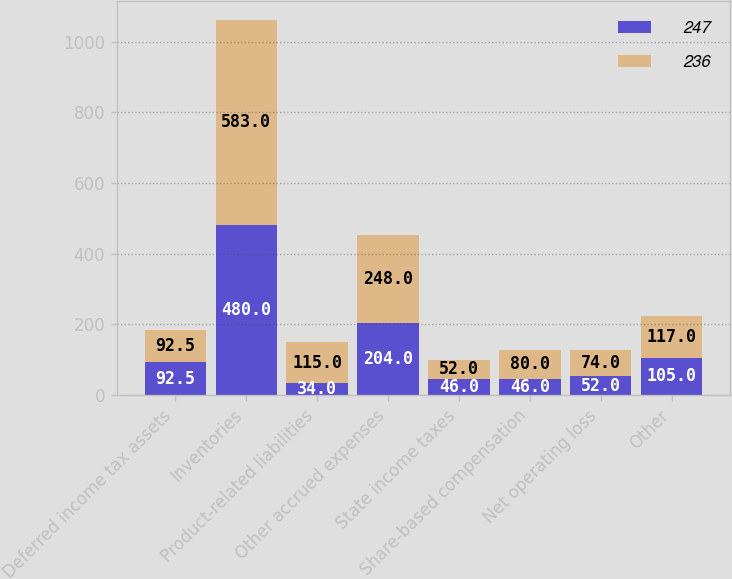<chart> <loc_0><loc_0><loc_500><loc_500><stacked_bar_chart><ecel><fcel>Deferred income tax assets<fcel>Inventories<fcel>Product-related liabilities<fcel>Other accrued expenses<fcel>State income taxes<fcel>Share-based compensation<fcel>Net operating loss<fcel>Other<nl><fcel>247<fcel>92.5<fcel>480<fcel>34<fcel>204<fcel>46<fcel>46<fcel>52<fcel>105<nl><fcel>236<fcel>92.5<fcel>583<fcel>115<fcel>248<fcel>52<fcel>80<fcel>74<fcel>117<nl></chart> 